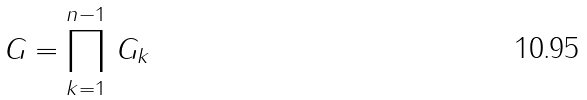Convert formula to latex. <formula><loc_0><loc_0><loc_500><loc_500>G = \prod _ { k = 1 } ^ { n - 1 } \, G _ { k }</formula> 